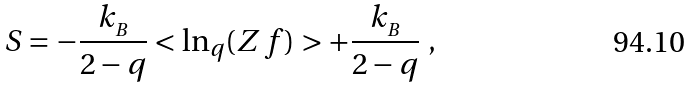<formula> <loc_0><loc_0><loc_500><loc_500>S = - \frac { k _ { _ { B } } } { 2 - q } < \ln _ { q } ( Z \, f ) > + \frac { k _ { _ { B } } } { 2 - q } \ ,</formula> 